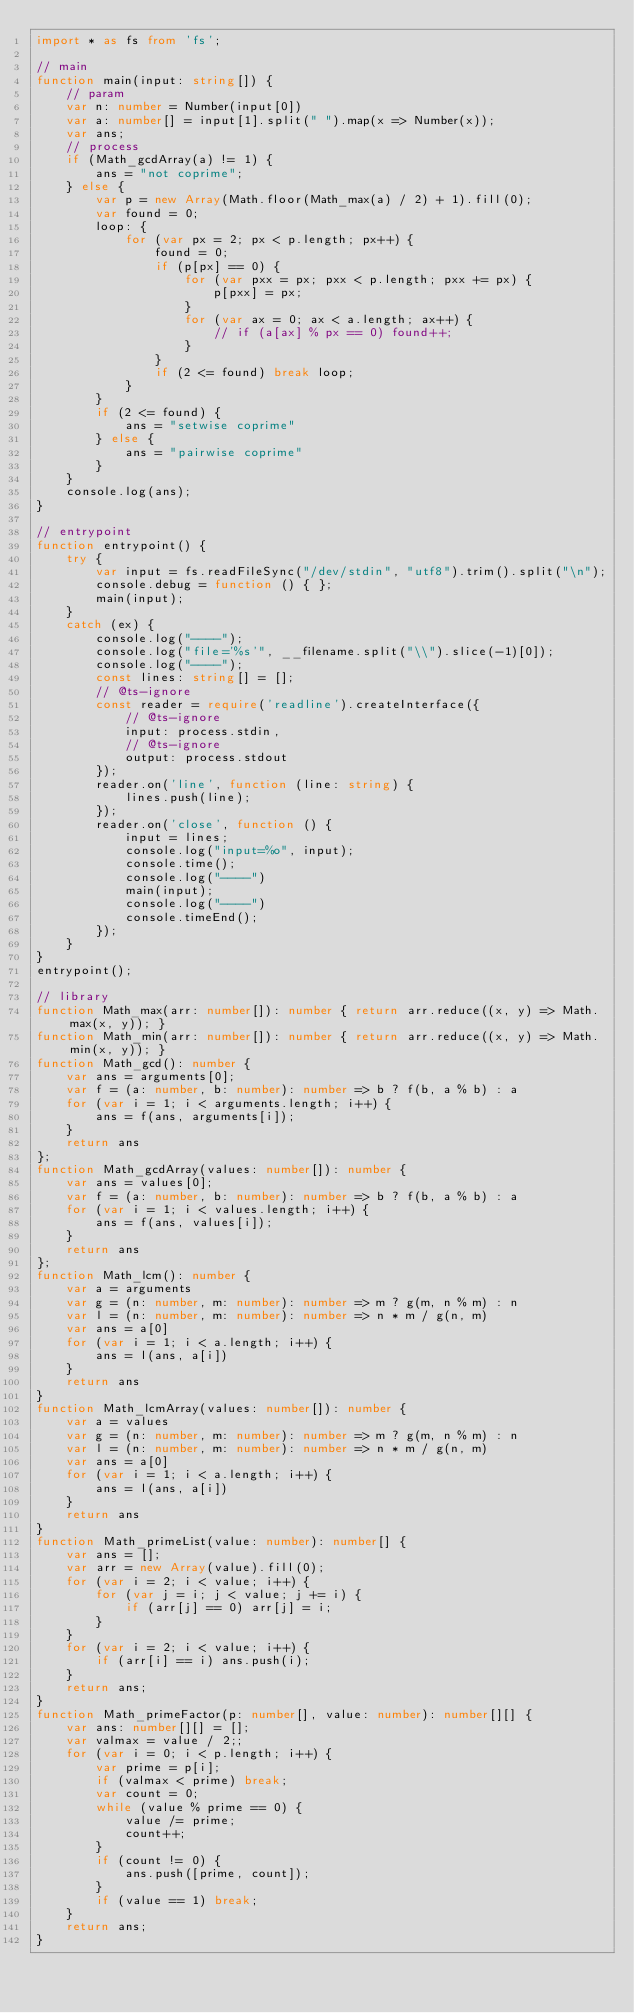Convert code to text. <code><loc_0><loc_0><loc_500><loc_500><_TypeScript_>import * as fs from 'fs';

// main
function main(input: string[]) {
    // param
    var n: number = Number(input[0])
    var a: number[] = input[1].split(" ").map(x => Number(x));
    var ans;
    // process
    if (Math_gcdArray(a) != 1) {
        ans = "not coprime";
    } else {
        var p = new Array(Math.floor(Math_max(a) / 2) + 1).fill(0);
        var found = 0;
        loop: {
            for (var px = 2; px < p.length; px++) {
                found = 0;
                if (p[px] == 0) {
                    for (var pxx = px; pxx < p.length; pxx += px) {
                        p[pxx] = px;
                    }
                    for (var ax = 0; ax < a.length; ax++) {
                        // if (a[ax] % px == 0) found++;
                    }
                }
                if (2 <= found) break loop;
            }
        }
        if (2 <= found) {
            ans = "setwise coprime"
        } else {
            ans = "pairwise coprime"
        }
    }
    console.log(ans);
}

// entrypoint
function entrypoint() {
    try {
        var input = fs.readFileSync("/dev/stdin", "utf8").trim().split("\n");
        console.debug = function () { };
        main(input);
    }
    catch (ex) {
        console.log("----");
        console.log("file='%s'", __filename.split("\\").slice(-1)[0]);
        console.log("----");
        const lines: string[] = [];
        // @ts-ignore
        const reader = require('readline').createInterface({
            // @ts-ignore
            input: process.stdin,
            // @ts-ignore
            output: process.stdout
        });
        reader.on('line', function (line: string) {
            lines.push(line);
        });
        reader.on('close', function () {
            input = lines;
            console.log("input=%o", input);
            console.time();
            console.log("----")
            main(input);
            console.log("----")
            console.timeEnd();
        });
    }
}
entrypoint();

// library
function Math_max(arr: number[]): number { return arr.reduce((x, y) => Math.max(x, y)); }
function Math_min(arr: number[]): number { return arr.reduce((x, y) => Math.min(x, y)); }
function Math_gcd(): number {
    var ans = arguments[0];
    var f = (a: number, b: number): number => b ? f(b, a % b) : a
    for (var i = 1; i < arguments.length; i++) {
        ans = f(ans, arguments[i]);
    }
    return ans
};
function Math_gcdArray(values: number[]): number {
    var ans = values[0];
    var f = (a: number, b: number): number => b ? f(b, a % b) : a
    for (var i = 1; i < values.length; i++) {
        ans = f(ans, values[i]);
    }
    return ans
};
function Math_lcm(): number {
    var a = arguments
    var g = (n: number, m: number): number => m ? g(m, n % m) : n
    var l = (n: number, m: number): number => n * m / g(n, m)
    var ans = a[0]
    for (var i = 1; i < a.length; i++) {
        ans = l(ans, a[i])
    }
    return ans
}
function Math_lcmArray(values: number[]): number {
    var a = values
    var g = (n: number, m: number): number => m ? g(m, n % m) : n
    var l = (n: number, m: number): number => n * m / g(n, m)
    var ans = a[0]
    for (var i = 1; i < a.length; i++) {
        ans = l(ans, a[i])
    }
    return ans
}
function Math_primeList(value: number): number[] {
    var ans = [];
    var arr = new Array(value).fill(0);
    for (var i = 2; i < value; i++) {
        for (var j = i; j < value; j += i) {
            if (arr[j] == 0) arr[j] = i;
        }
    }
    for (var i = 2; i < value; i++) {
        if (arr[i] == i) ans.push(i);
    }
    return ans;
}
function Math_primeFactor(p: number[], value: number): number[][] {
    var ans: number[][] = [];
    var valmax = value / 2;;
    for (var i = 0; i < p.length; i++) {
        var prime = p[i];
        if (valmax < prime) break;
        var count = 0;
        while (value % prime == 0) {
            value /= prime;
            count++;
        }
        if (count != 0) {
            ans.push([prime, count]);
        }
        if (value == 1) break;
    }
    return ans;
}
</code> 